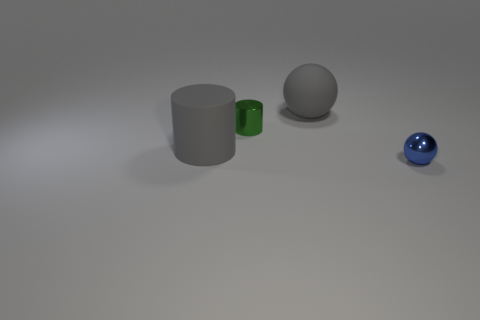There is a large matte cylinder; is its color the same as the large matte sphere that is right of the large cylinder?
Ensure brevity in your answer.  Yes. Is the material of the large sphere the same as the large gray cylinder?
Your answer should be very brief. Yes. The rubber cylinder that is the same color as the matte sphere is what size?
Provide a succinct answer. Large. Are there any large rubber balls that have the same color as the rubber cylinder?
Provide a short and direct response. Yes. There is a cylinder that is made of the same material as the big ball; what is its size?
Keep it short and to the point. Large. The large object in front of the rubber object that is on the right side of the tiny object that is behind the matte cylinder is what shape?
Provide a succinct answer. Cylinder. What size is the gray object that is the same shape as the small green object?
Offer a terse response. Large. How big is the object that is both on the right side of the green cylinder and in front of the tiny green cylinder?
Ensure brevity in your answer.  Small. What is the shape of the rubber object that is the same color as the matte cylinder?
Your answer should be compact. Sphere. What color is the tiny shiny cylinder?
Ensure brevity in your answer.  Green. 